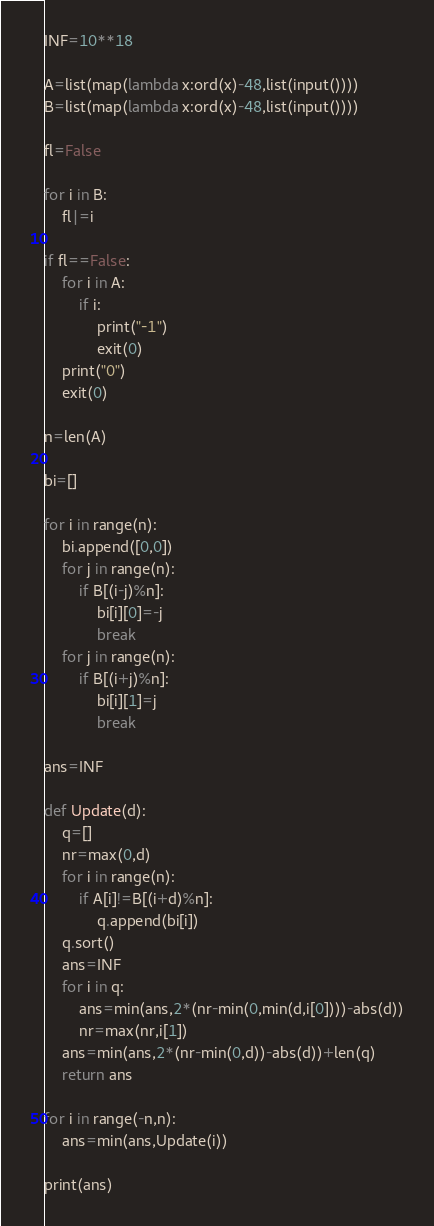<code> <loc_0><loc_0><loc_500><loc_500><_Python_>INF=10**18

A=list(map(lambda x:ord(x)-48,list(input())))
B=list(map(lambda x:ord(x)-48,list(input())))

fl=False

for i in B:
	fl|=i

if fl==False:
	for i in A:
		if i:
			print("-1")
			exit(0)
	print("0")
	exit(0)

n=len(A)

bi=[]

for i in range(n):
	bi.append([0,0])
	for j in range(n):
		if B[(i-j)%n]:
			bi[i][0]=-j
			break
	for j in range(n):
		if B[(i+j)%n]:
			bi[i][1]=j
			break

ans=INF

def Update(d):
	q=[]
	nr=max(0,d)
	for i in range(n):
		if A[i]!=B[(i+d)%n]:
			q.append(bi[i])
	q.sort()
	ans=INF
	for i in q:
		ans=min(ans,2*(nr-min(0,min(d,i[0])))-abs(d))
		nr=max(nr,i[1])
	ans=min(ans,2*(nr-min(0,d))-abs(d))+len(q)
	return ans

for i in range(-n,n):
	ans=min(ans,Update(i))

print(ans)
</code> 